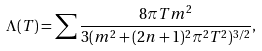Convert formula to latex. <formula><loc_0><loc_0><loc_500><loc_500>\Lambda ( T ) = \sum \frac { 8 \pi T m ^ { 2 } } { 3 ( m ^ { 2 } + ( 2 n + 1 ) ^ { 2 } \pi ^ { 2 } T ^ { 2 } ) ^ { 3 / 2 } } ,</formula> 